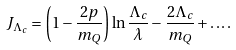Convert formula to latex. <formula><loc_0><loc_0><loc_500><loc_500>J _ { \Lambda _ { c } } = \left ( 1 - \frac { 2 p } { m _ { Q } } \right ) \ln \frac { \Lambda _ { c } } { \lambda } - \frac { 2 \Lambda _ { c } } { m _ { Q } } + \dots .</formula> 